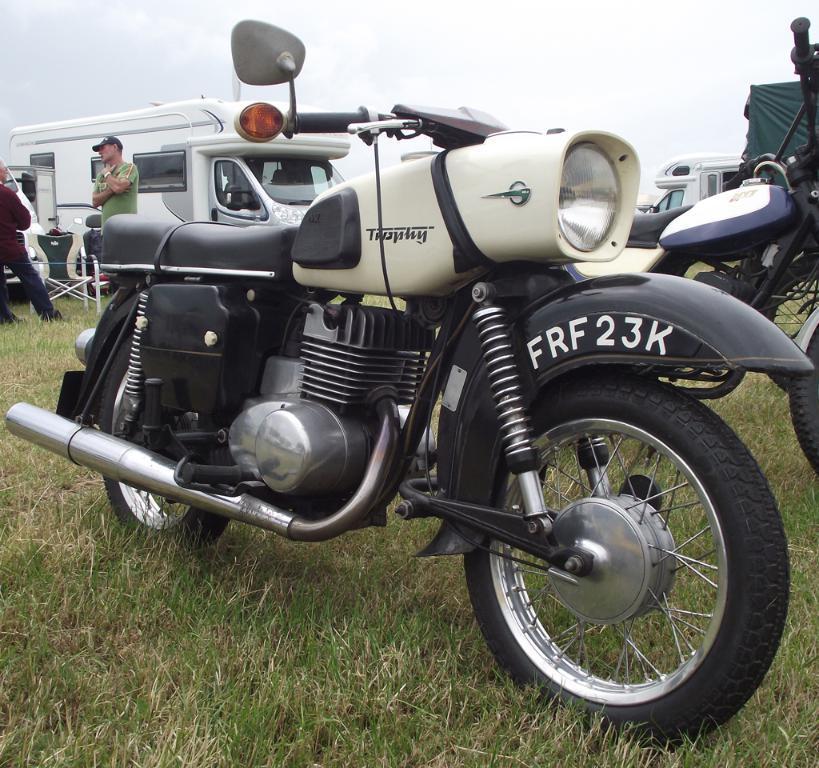How would you summarize this image in a sentence or two? In the center of the image there is a bike on the grass. in the background we can see vehicles, bike, chair, sky and clouds. 